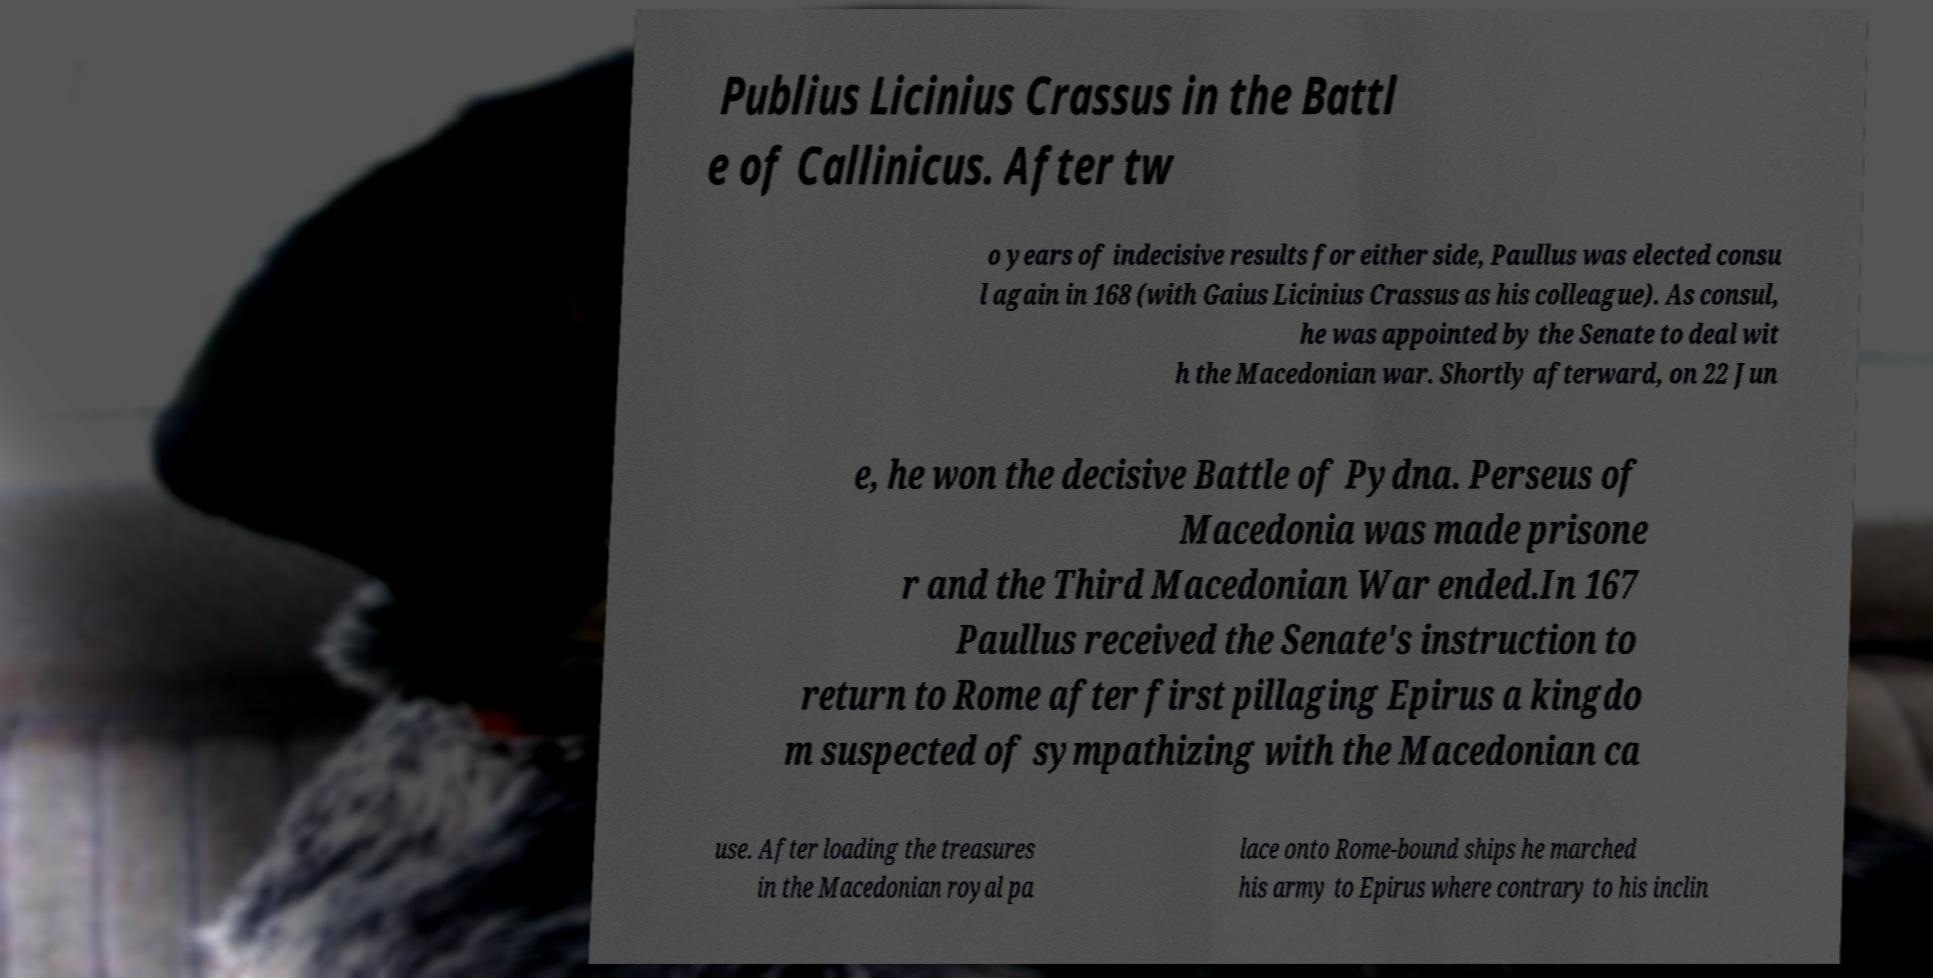Can you read and provide the text displayed in the image?This photo seems to have some interesting text. Can you extract and type it out for me? Publius Licinius Crassus in the Battl e of Callinicus. After tw o years of indecisive results for either side, Paullus was elected consu l again in 168 (with Gaius Licinius Crassus as his colleague). As consul, he was appointed by the Senate to deal wit h the Macedonian war. Shortly afterward, on 22 Jun e, he won the decisive Battle of Pydna. Perseus of Macedonia was made prisone r and the Third Macedonian War ended.In 167 Paullus received the Senate's instruction to return to Rome after first pillaging Epirus a kingdo m suspected of sympathizing with the Macedonian ca use. After loading the treasures in the Macedonian royal pa lace onto Rome-bound ships he marched his army to Epirus where contrary to his inclin 